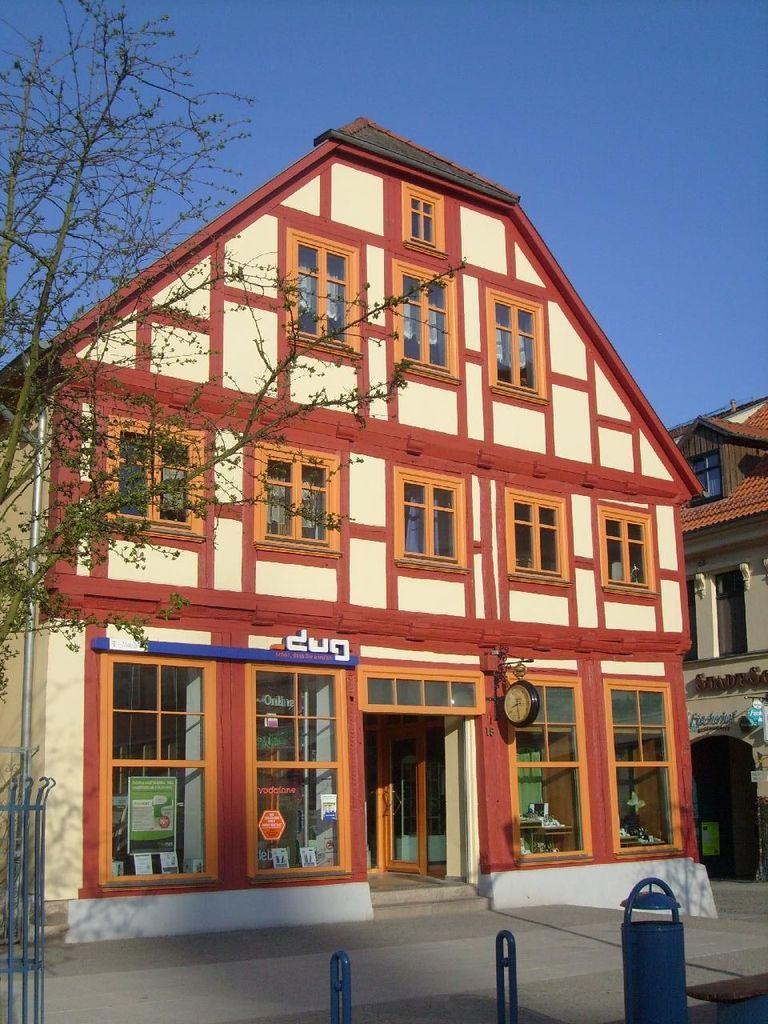Please provide a concise description of this image. In this image I can see a house , in front of house I can see a road ,at the bottom I can see stand , at the top I can see the sky ,on the right side I can see another building. 